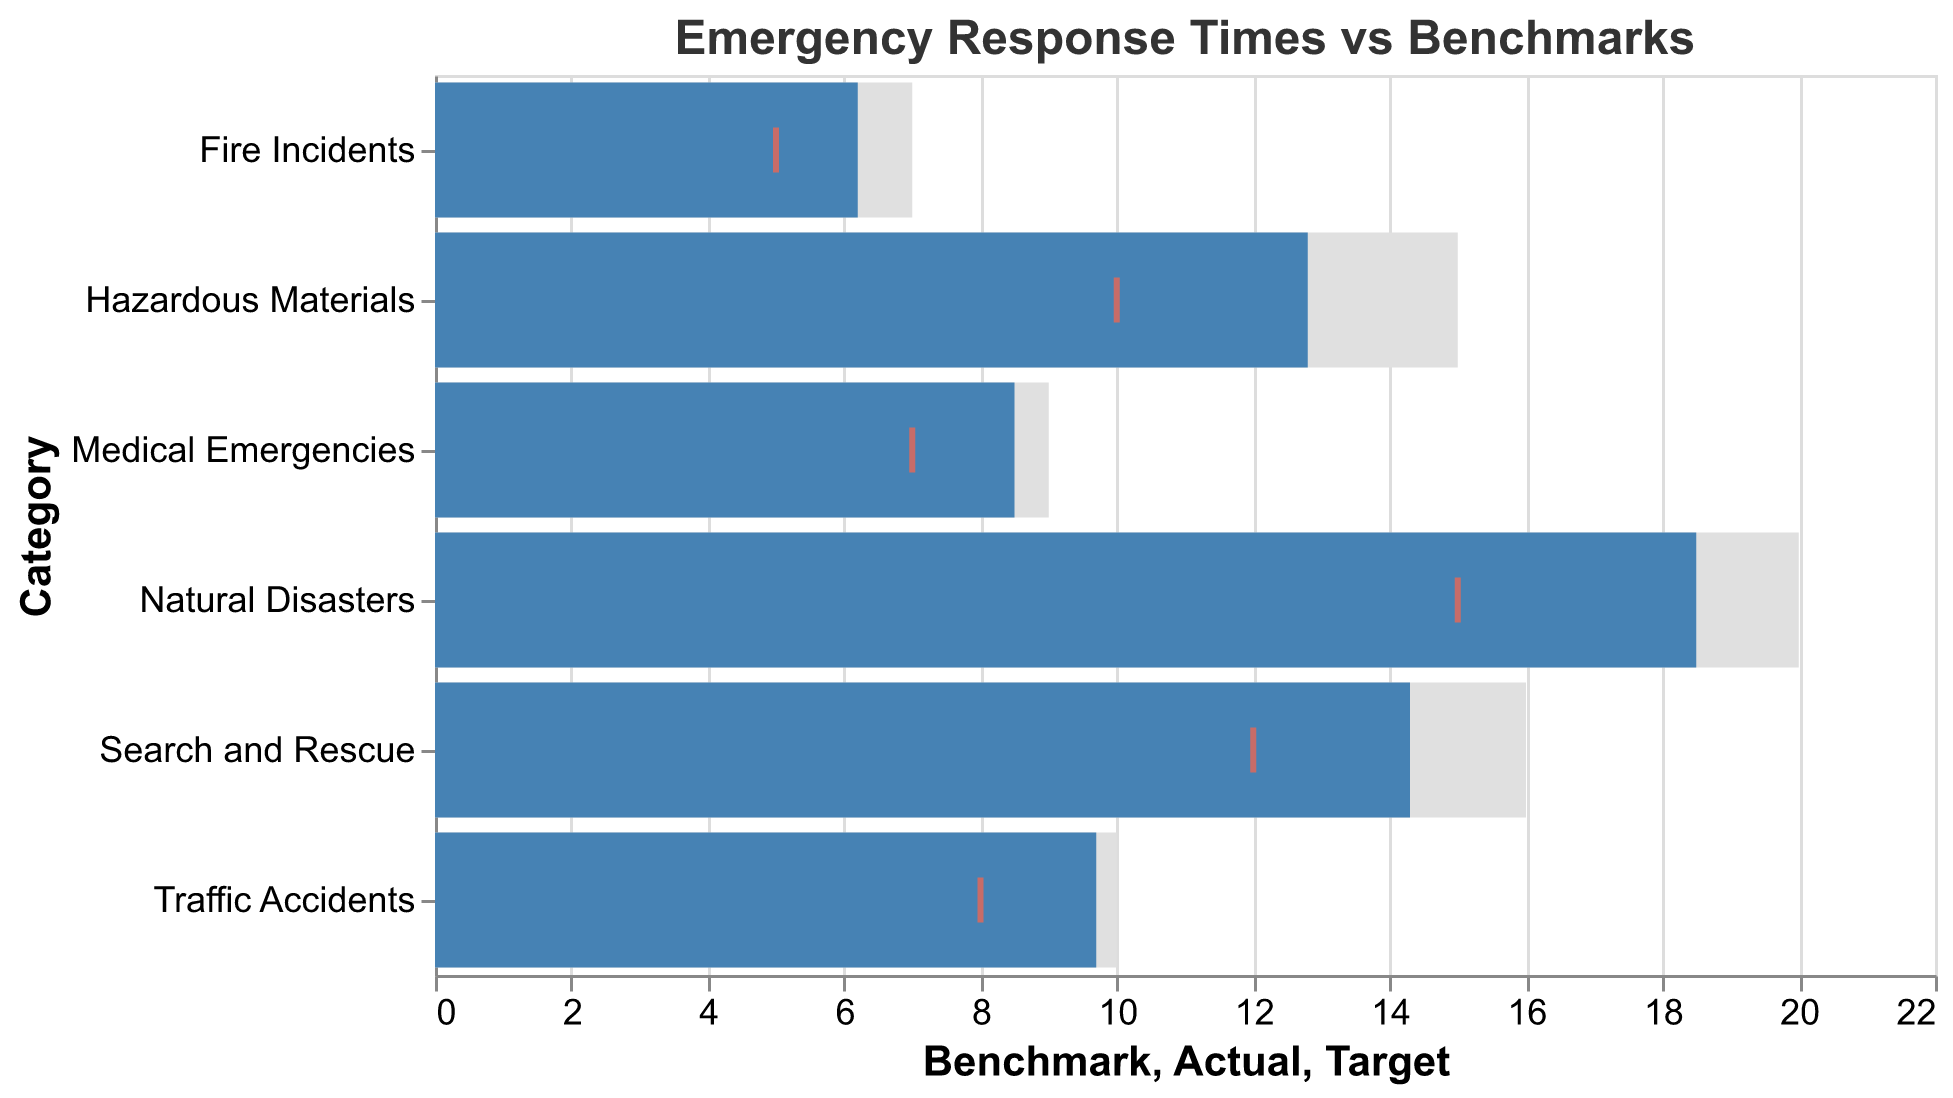What is the title of the chart? The title of the chart is located at the top and says "Emergency Response Times vs Benchmarks".
Answer: Emergency Response Times vs Benchmarks How many categories of incidents are compared in the chart? By counting the different categories listed on the y-axis, we find that there are six categories of incidents being compared.
Answer: 6 Which category has the closest actual response time to its target time? To find the closest actual response time to the target time, look at the length of the blue bars (Actual) and compare them to the red ticks (Target). The category "Fire Incidents" has an actual time of 6.2 which is closest to its target time of 5.
Answer: Fire Incidents What are the benchmark and target response times for Traffic Accidents? The benchmark and target times for Traffic Accidents can be read from the chart. The benchmark time is 10 and the target time is 8.
Answer: Benchmark: 10, Target: 8 Which incident type has the largest gap between its actual response time and the target time? To find the largest gap, subtract the target time from the actual time for each category. The largest gap is for "Natural Disasters" where the actual time is 18.5 and the target time is 15, resulting in a gap of 3.5.
Answer: Natural Disasters What is the difference between the actual and benchmark response times for Hazardous Materials? Subtract the actual response time (12.8) from the benchmark response time (15) for Hazardous Materials to find the difference. The difference is 15 - 12.8 = 2.2.
Answer: 2.2 Compare the actual response times for Medical Emergencies and Search and Rescue. Which is higher? Refer to the blue bars representing actual response times. Medical Emergencies have an actual response time of 8.5, while Search and Rescue have an actual response time of 14.3. Therefore, Search and Rescue is higher.
Answer: Search and Rescue What is the average actual response time across all categories? Sum the actual response times for all categories and divide by the number of categories (6). The actual times are: 6.2, 8.5, 12.8, 18.5, 9.7, and 14.3. The sum is 70. Add these and divide by 6 to get the average: 70/6 ≈ 11.67.
Answer: 11.67 Between Traffic Accidents and Fire Incidents, which one has a greater difference between its benchmark and target response times? Compare the differences for both categories. For Traffic Accidents, the benchmark is 10 and the target is 8, so the difference is 2. For Fire Incidents, the benchmark is 7 and the target is 5, so the difference is also 2. Both have the same difference.
Answer: Same Which category meets its benchmark best, and how can this be determined from the chart? To determine which category meets its benchmark best, find the category where the blue bar (actual time) is closest to the gray bar (benchmark) or even lower. "Fire Incidents" has an actual time of 6.2 compared to a benchmark of 7, showing the best performance relative to its benchmark.
Answer: Fire Incidents 